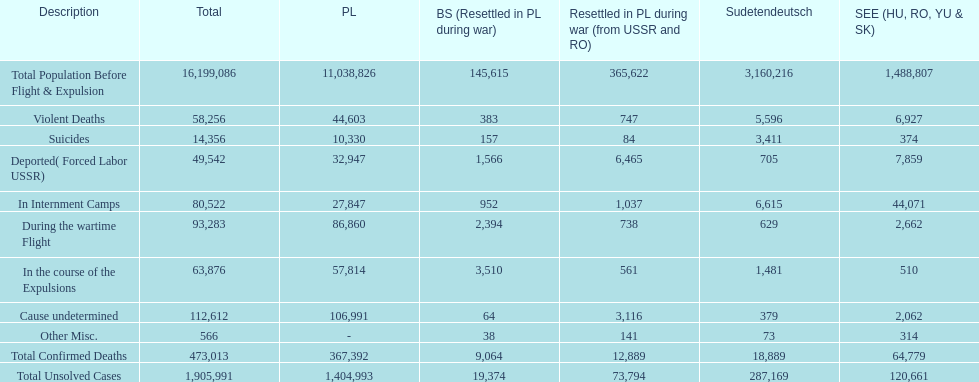Where was the smallest total of uncracked cases found? Baltic States(Resettled in Poland during war). 